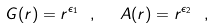Convert formula to latex. <formula><loc_0><loc_0><loc_500><loc_500>G ( r ) = r ^ { \epsilon _ { 1 } } \ , \ \ A ( r ) = r ^ { \epsilon _ { 2 } } \ ,</formula> 